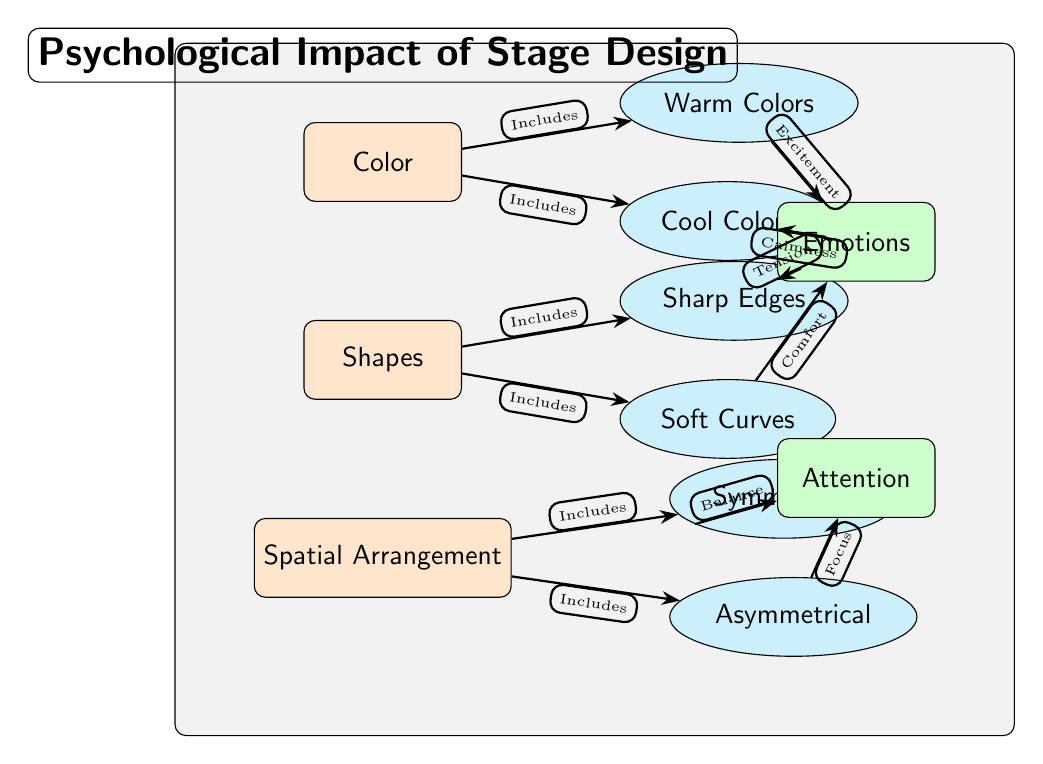What are the three main components in the diagram? The diagram lists three main components: Color, Shapes, and Spatial Arrangement. These are the primary classifications that influence audience perception.
Answer: Color, Shapes, Spatial Arrangement How many sub-nodes are associated with the Color node? The Color node has two sub-nodes: Warm Colors and Cool Colors, which detail the types of colors that impact emotions.
Answer: 2 What emotion is linked to Cool Colors? The diagram indicates that Cool Colors are associated with Calmness, which shows how color influences emotional responses.
Answer: Calmness What type of shapes is associated with Tension? Sharp Edges are linked with the emotion of Tension, as shown in the diagram's connections, indicating how certain shapes can evoke specific feelings.
Answer: Sharp Edges Which spatial arrangement is linked to Balance? The spatial arrangement of Symmetrical is connected to the emotion of Balance, demonstrating how this arrangement affects audience attention positively.
Answer: Symmetrical What does Asymmetrical spatial arrangement promote? The diagram shows that Asymmetrical spatial arrangement promotes Focus, indicating how uneven arrangements can direct attention effectively.
Answer: Focus How does Warm Colors affect emotions? Warm Colors lead to the emotion of Excitement, as depicted in the connections from warm colors to emotional outputs in the diagram.
Answer: Excitement What is the overall impact of the diagram's components? The diagram illustrates that Color, Shapes, and Spatial Arrangement collectively influence Emotions and Attention among the audience, emphasizing their importance in stage design.
Answer: Emotions and Attention 